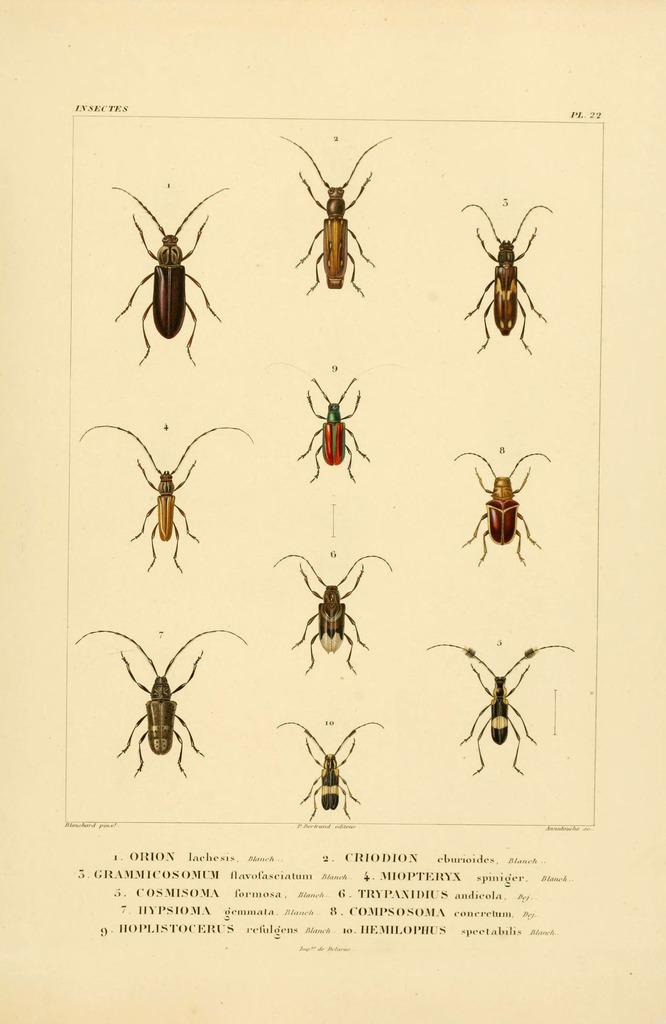What is featured on the poster in the image? There is a poster in the image that contains insects. Can you describe the insects on the poster? The insects have various colors, including red, green, black, brown, and cream. What else can be seen on the poster besides the insects? There are words written at the bottom of the poster. How many trees are depicted on the poster? There are no trees depicted on the poster; it features insects and words. What type of approval or agreement is shown on the poster? There is no approval or agreement depicted on the poster; it focuses on insects and their colors. 